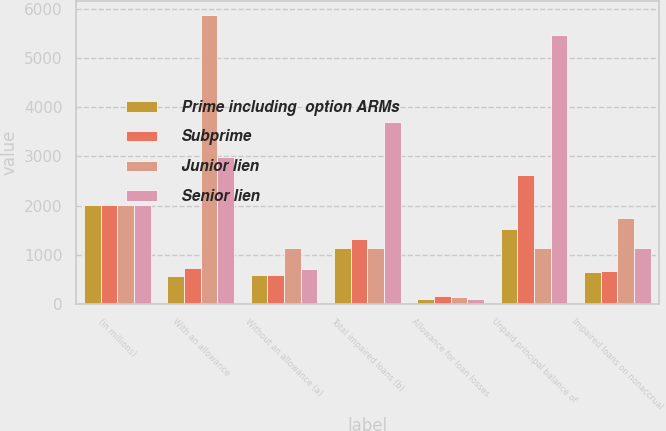Convert chart. <chart><loc_0><loc_0><loc_500><loc_500><stacked_bar_chart><ecel><fcel>(in millions)<fcel>With an allowance<fcel>Without an allowance (a)<fcel>Total impaired loans (b)<fcel>Allowance for loan losses<fcel>Unpaid principal balance of<fcel>Impaired loans on nonaccrual<nl><fcel>Prime including  option ARMs<fcel>2013<fcel>567<fcel>579<fcel>1146<fcel>94<fcel>1515<fcel>641<nl><fcel>Subprime<fcel>2013<fcel>727<fcel>592<fcel>1319<fcel>162<fcel>2625<fcel>666<nl><fcel>Junior lien<fcel>2013<fcel>5871<fcel>1133<fcel>1139.5<fcel>144<fcel>1139.5<fcel>1737<nl><fcel>Senior lien<fcel>2013<fcel>2989<fcel>709<fcel>3698<fcel>94<fcel>5461<fcel>1127<nl></chart> 